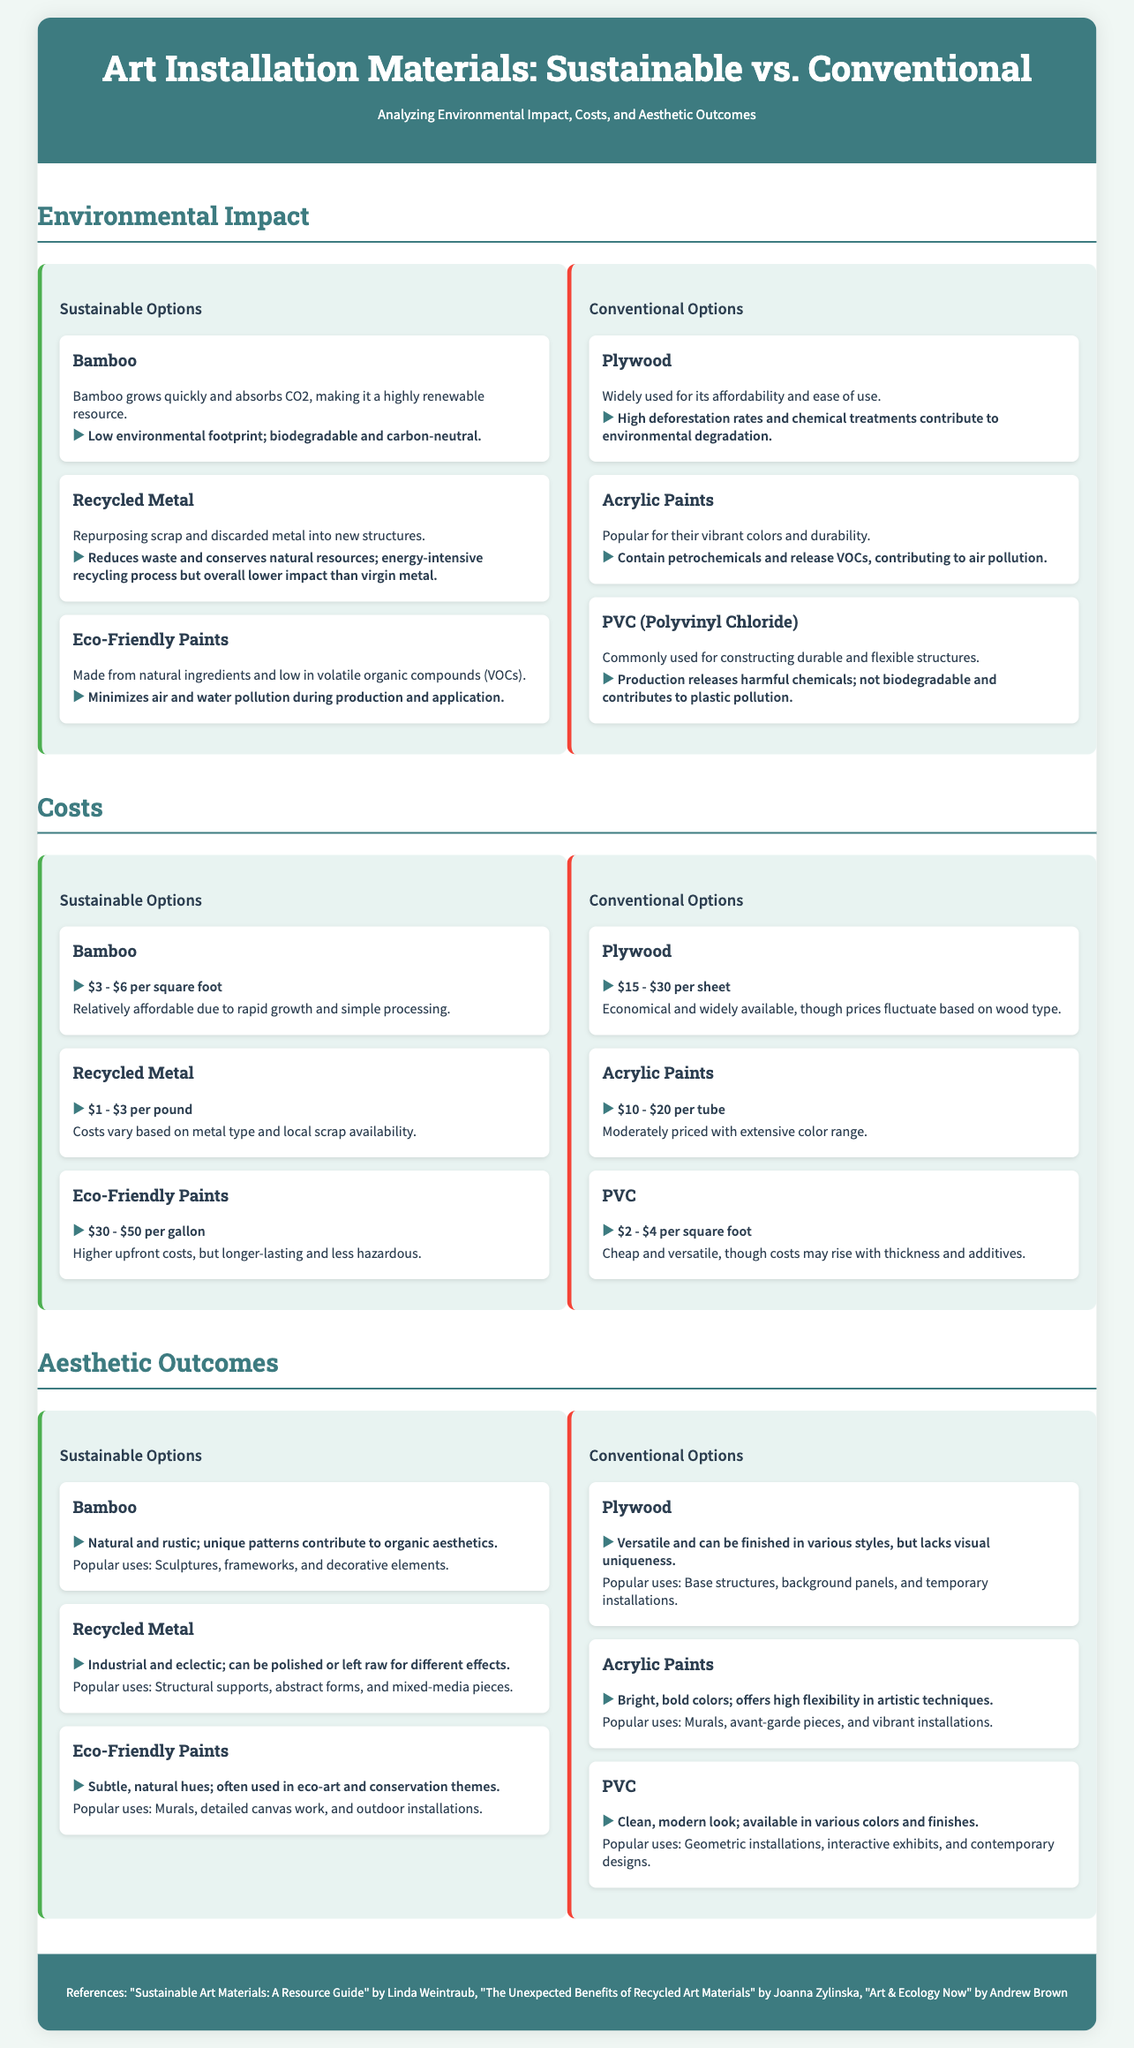What is the cost range for bamboo? The cost range for bamboo is specifically mentioned in the document under sustainable options, which states it is $3 - $6 per square foot.
Answer: $3 - $6 per square foot What material has a low environmental footprint? The document states that bamboo has a low environmental footprint, making it highly renewable and biodegradable.
Answer: Bamboo What is the price range for recycled metal? The document outlines the price range for recycled metal as $1 - $3 per pound, based on local availability.
Answer: $1 - $3 per pound Which sustainable option is associated with industrial aesthetics? The document refers to recycled metal as having an industrial and eclectic aesthetic related to art installations.
Answer: Recycled Metal What is a common use for acrylic paints? The document lists murals, avant-garde pieces, and vibrant installations as popular uses for acrylic paints.
Answer: Murals, avant-garde pieces, and vibrant installations Which material is noted for high deforestation rates? The document specifies plywood as being associated with high deforestation rates and chemical treatments.
Answer: Plywood What are eco-friendly paints made from? The document states that eco-friendly paints are made from natural ingredients and are low in volatile organic compounds.
Answer: Natural ingredients What unique aesthetic does bamboo contribute to art installations? The document elaborates that bamboo offers a natural and rustic aesthetic with unique patterns, central to organic aesthetics.
Answer: Natural and rustic What does PVC production contribute to? The document mentions that PVC production releases harmful chemicals and contributes to plastic pollution.
Answer: Plastic pollution 